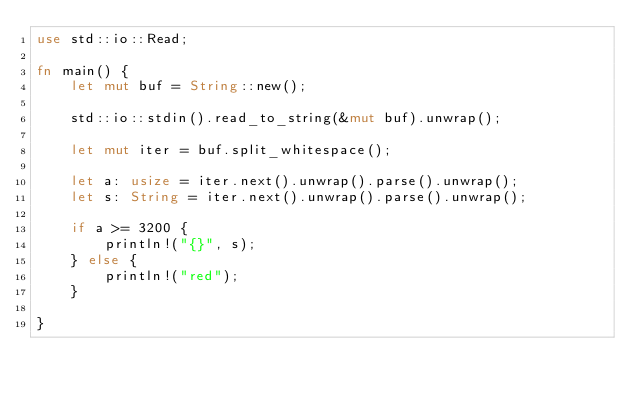Convert code to text. <code><loc_0><loc_0><loc_500><loc_500><_Rust_>use std::io::Read;

fn main() {
    let mut buf = String::new();

    std::io::stdin().read_to_string(&mut buf).unwrap();

    let mut iter = buf.split_whitespace();

    let a: usize = iter.next().unwrap().parse().unwrap();
    let s: String = iter.next().unwrap().parse().unwrap();

    if a >= 3200 {
        println!("{}", s);
    } else {
        println!("red");
    }

}</code> 